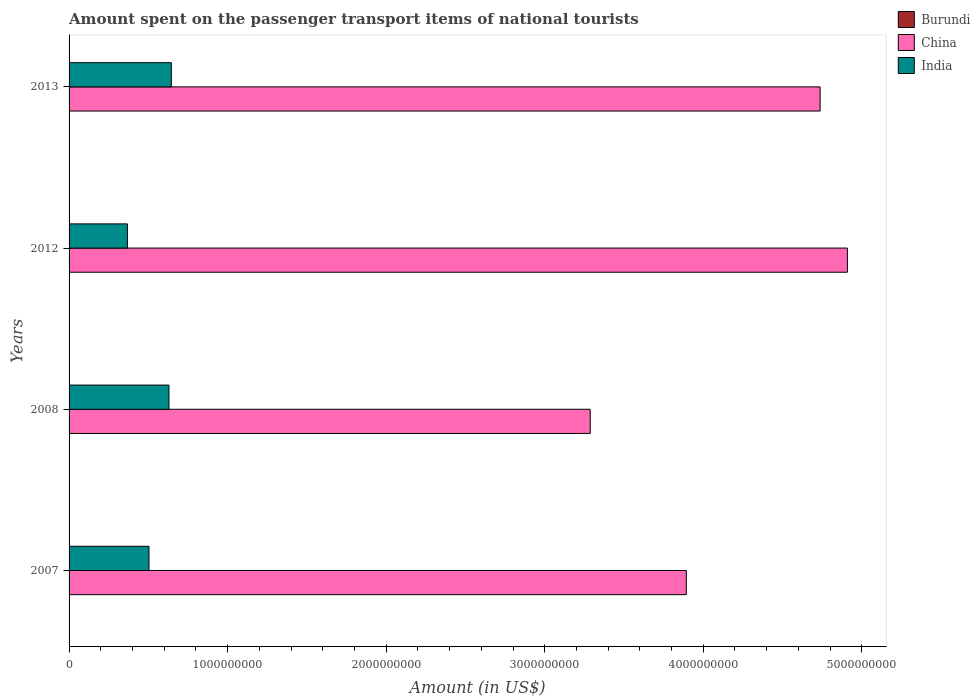How many different coloured bars are there?
Make the answer very short. 3. How many groups of bars are there?
Offer a very short reply. 4. Are the number of bars per tick equal to the number of legend labels?
Provide a short and direct response. Yes. Are the number of bars on each tick of the Y-axis equal?
Keep it short and to the point. Yes. How many bars are there on the 1st tick from the bottom?
Give a very brief answer. 3. What is the label of the 2nd group of bars from the top?
Offer a terse response. 2012. In how many cases, is the number of bars for a given year not equal to the number of legend labels?
Your answer should be compact. 0. What is the amount spent on the passenger transport items of national tourists in India in 2008?
Give a very brief answer. 6.30e+08. Across all years, what is the maximum amount spent on the passenger transport items of national tourists in China?
Provide a succinct answer. 4.91e+09. Across all years, what is the minimum amount spent on the passenger transport items of national tourists in Burundi?
Provide a short and direct response. 3.00e+05. In which year was the amount spent on the passenger transport items of national tourists in India maximum?
Make the answer very short. 2013. In which year was the amount spent on the passenger transport items of national tourists in China minimum?
Ensure brevity in your answer.  2008. What is the total amount spent on the passenger transport items of national tourists in China in the graph?
Your answer should be very brief. 1.68e+1. What is the difference between the amount spent on the passenger transport items of national tourists in India in 2007 and that in 2013?
Provide a succinct answer. -1.41e+08. What is the difference between the amount spent on the passenger transport items of national tourists in China in 2008 and the amount spent on the passenger transport items of national tourists in Burundi in 2007?
Your answer should be very brief. 3.29e+09. What is the average amount spent on the passenger transport items of national tourists in Burundi per year?
Give a very brief answer. 8.25e+05. In the year 2008, what is the difference between the amount spent on the passenger transport items of national tourists in Burundi and amount spent on the passenger transport items of national tourists in India?
Offer a terse response. -6.30e+08. In how many years, is the amount spent on the passenger transport items of national tourists in China greater than 600000000 US$?
Provide a succinct answer. 4. What is the ratio of the amount spent on the passenger transport items of national tourists in China in 2007 to that in 2008?
Keep it short and to the point. 1.18. Is the amount spent on the passenger transport items of national tourists in China in 2007 less than that in 2013?
Ensure brevity in your answer.  Yes. What is the difference between the highest and the second highest amount spent on the passenger transport items of national tourists in China?
Your answer should be compact. 1.72e+08. What is the difference between the highest and the lowest amount spent on the passenger transport items of national tourists in China?
Give a very brief answer. 1.62e+09. In how many years, is the amount spent on the passenger transport items of national tourists in Burundi greater than the average amount spent on the passenger transport items of national tourists in Burundi taken over all years?
Your answer should be compact. 2. Is it the case that in every year, the sum of the amount spent on the passenger transport items of national tourists in Burundi and amount spent on the passenger transport items of national tourists in India is greater than the amount spent on the passenger transport items of national tourists in China?
Give a very brief answer. No. How many bars are there?
Provide a short and direct response. 12. Are the values on the major ticks of X-axis written in scientific E-notation?
Make the answer very short. No. Where does the legend appear in the graph?
Offer a terse response. Top right. How are the legend labels stacked?
Make the answer very short. Vertical. What is the title of the graph?
Offer a very short reply. Amount spent on the passenger transport items of national tourists. What is the label or title of the Y-axis?
Provide a succinct answer. Years. What is the Amount (in US$) of Burundi in 2007?
Provide a succinct answer. 1.00e+06. What is the Amount (in US$) in China in 2007?
Make the answer very short. 3.89e+09. What is the Amount (in US$) in India in 2007?
Ensure brevity in your answer.  5.04e+08. What is the Amount (in US$) in China in 2008?
Keep it short and to the point. 3.29e+09. What is the Amount (in US$) in India in 2008?
Your answer should be compact. 6.30e+08. What is the Amount (in US$) in Burundi in 2012?
Offer a very short reply. 1.20e+06. What is the Amount (in US$) of China in 2012?
Your answer should be compact. 4.91e+09. What is the Amount (in US$) of India in 2012?
Keep it short and to the point. 3.68e+08. What is the Amount (in US$) in China in 2013?
Keep it short and to the point. 4.74e+09. What is the Amount (in US$) of India in 2013?
Provide a short and direct response. 6.45e+08. Across all years, what is the maximum Amount (in US$) of Burundi?
Your answer should be very brief. 1.20e+06. Across all years, what is the maximum Amount (in US$) of China?
Keep it short and to the point. 4.91e+09. Across all years, what is the maximum Amount (in US$) of India?
Offer a terse response. 6.45e+08. Across all years, what is the minimum Amount (in US$) in China?
Your answer should be very brief. 3.29e+09. Across all years, what is the minimum Amount (in US$) of India?
Provide a short and direct response. 3.68e+08. What is the total Amount (in US$) in Burundi in the graph?
Provide a short and direct response. 3.30e+06. What is the total Amount (in US$) in China in the graph?
Ensure brevity in your answer.  1.68e+1. What is the total Amount (in US$) in India in the graph?
Ensure brevity in your answer.  2.15e+09. What is the difference between the Amount (in US$) of China in 2007 and that in 2008?
Offer a very short reply. 6.06e+08. What is the difference between the Amount (in US$) of India in 2007 and that in 2008?
Offer a terse response. -1.26e+08. What is the difference between the Amount (in US$) in Burundi in 2007 and that in 2012?
Give a very brief answer. -2.00e+05. What is the difference between the Amount (in US$) in China in 2007 and that in 2012?
Offer a very short reply. -1.02e+09. What is the difference between the Amount (in US$) in India in 2007 and that in 2012?
Offer a very short reply. 1.36e+08. What is the difference between the Amount (in US$) of Burundi in 2007 and that in 2013?
Offer a very short reply. 2.00e+05. What is the difference between the Amount (in US$) in China in 2007 and that in 2013?
Provide a short and direct response. -8.44e+08. What is the difference between the Amount (in US$) in India in 2007 and that in 2013?
Provide a short and direct response. -1.41e+08. What is the difference between the Amount (in US$) in Burundi in 2008 and that in 2012?
Make the answer very short. -9.00e+05. What is the difference between the Amount (in US$) of China in 2008 and that in 2012?
Provide a short and direct response. -1.62e+09. What is the difference between the Amount (in US$) in India in 2008 and that in 2012?
Make the answer very short. 2.62e+08. What is the difference between the Amount (in US$) of Burundi in 2008 and that in 2013?
Make the answer very short. -5.00e+05. What is the difference between the Amount (in US$) of China in 2008 and that in 2013?
Give a very brief answer. -1.45e+09. What is the difference between the Amount (in US$) in India in 2008 and that in 2013?
Ensure brevity in your answer.  -1.50e+07. What is the difference between the Amount (in US$) in Burundi in 2012 and that in 2013?
Make the answer very short. 4.00e+05. What is the difference between the Amount (in US$) of China in 2012 and that in 2013?
Make the answer very short. 1.72e+08. What is the difference between the Amount (in US$) in India in 2012 and that in 2013?
Give a very brief answer. -2.77e+08. What is the difference between the Amount (in US$) of Burundi in 2007 and the Amount (in US$) of China in 2008?
Give a very brief answer. -3.29e+09. What is the difference between the Amount (in US$) in Burundi in 2007 and the Amount (in US$) in India in 2008?
Offer a terse response. -6.29e+08. What is the difference between the Amount (in US$) in China in 2007 and the Amount (in US$) in India in 2008?
Keep it short and to the point. 3.26e+09. What is the difference between the Amount (in US$) in Burundi in 2007 and the Amount (in US$) in China in 2012?
Your answer should be very brief. -4.91e+09. What is the difference between the Amount (in US$) of Burundi in 2007 and the Amount (in US$) of India in 2012?
Your answer should be compact. -3.67e+08. What is the difference between the Amount (in US$) in China in 2007 and the Amount (in US$) in India in 2012?
Your response must be concise. 3.52e+09. What is the difference between the Amount (in US$) of Burundi in 2007 and the Amount (in US$) of China in 2013?
Offer a terse response. -4.74e+09. What is the difference between the Amount (in US$) of Burundi in 2007 and the Amount (in US$) of India in 2013?
Offer a very short reply. -6.44e+08. What is the difference between the Amount (in US$) of China in 2007 and the Amount (in US$) of India in 2013?
Offer a very short reply. 3.25e+09. What is the difference between the Amount (in US$) in Burundi in 2008 and the Amount (in US$) in China in 2012?
Provide a short and direct response. -4.91e+09. What is the difference between the Amount (in US$) of Burundi in 2008 and the Amount (in US$) of India in 2012?
Ensure brevity in your answer.  -3.68e+08. What is the difference between the Amount (in US$) in China in 2008 and the Amount (in US$) in India in 2012?
Keep it short and to the point. 2.92e+09. What is the difference between the Amount (in US$) of Burundi in 2008 and the Amount (in US$) of China in 2013?
Ensure brevity in your answer.  -4.74e+09. What is the difference between the Amount (in US$) in Burundi in 2008 and the Amount (in US$) in India in 2013?
Offer a terse response. -6.45e+08. What is the difference between the Amount (in US$) of China in 2008 and the Amount (in US$) of India in 2013?
Give a very brief answer. 2.64e+09. What is the difference between the Amount (in US$) of Burundi in 2012 and the Amount (in US$) of China in 2013?
Keep it short and to the point. -4.74e+09. What is the difference between the Amount (in US$) of Burundi in 2012 and the Amount (in US$) of India in 2013?
Give a very brief answer. -6.44e+08. What is the difference between the Amount (in US$) of China in 2012 and the Amount (in US$) of India in 2013?
Give a very brief answer. 4.26e+09. What is the average Amount (in US$) of Burundi per year?
Offer a very short reply. 8.25e+05. What is the average Amount (in US$) of China per year?
Give a very brief answer. 4.21e+09. What is the average Amount (in US$) of India per year?
Your answer should be very brief. 5.37e+08. In the year 2007, what is the difference between the Amount (in US$) of Burundi and Amount (in US$) of China?
Your answer should be very brief. -3.89e+09. In the year 2007, what is the difference between the Amount (in US$) of Burundi and Amount (in US$) of India?
Your answer should be very brief. -5.03e+08. In the year 2007, what is the difference between the Amount (in US$) of China and Amount (in US$) of India?
Your answer should be very brief. 3.39e+09. In the year 2008, what is the difference between the Amount (in US$) in Burundi and Amount (in US$) in China?
Give a very brief answer. -3.29e+09. In the year 2008, what is the difference between the Amount (in US$) in Burundi and Amount (in US$) in India?
Provide a short and direct response. -6.30e+08. In the year 2008, what is the difference between the Amount (in US$) in China and Amount (in US$) in India?
Your answer should be compact. 2.66e+09. In the year 2012, what is the difference between the Amount (in US$) in Burundi and Amount (in US$) in China?
Keep it short and to the point. -4.91e+09. In the year 2012, what is the difference between the Amount (in US$) of Burundi and Amount (in US$) of India?
Provide a short and direct response. -3.67e+08. In the year 2012, what is the difference between the Amount (in US$) of China and Amount (in US$) of India?
Offer a very short reply. 4.54e+09. In the year 2013, what is the difference between the Amount (in US$) in Burundi and Amount (in US$) in China?
Your answer should be very brief. -4.74e+09. In the year 2013, what is the difference between the Amount (in US$) in Burundi and Amount (in US$) in India?
Ensure brevity in your answer.  -6.44e+08. In the year 2013, what is the difference between the Amount (in US$) of China and Amount (in US$) of India?
Offer a very short reply. 4.09e+09. What is the ratio of the Amount (in US$) in Burundi in 2007 to that in 2008?
Give a very brief answer. 3.33. What is the ratio of the Amount (in US$) of China in 2007 to that in 2008?
Keep it short and to the point. 1.18. What is the ratio of the Amount (in US$) in Burundi in 2007 to that in 2012?
Your answer should be very brief. 0.83. What is the ratio of the Amount (in US$) of China in 2007 to that in 2012?
Make the answer very short. 0.79. What is the ratio of the Amount (in US$) in India in 2007 to that in 2012?
Offer a terse response. 1.37. What is the ratio of the Amount (in US$) in China in 2007 to that in 2013?
Give a very brief answer. 0.82. What is the ratio of the Amount (in US$) in India in 2007 to that in 2013?
Keep it short and to the point. 0.78. What is the ratio of the Amount (in US$) in China in 2008 to that in 2012?
Make the answer very short. 0.67. What is the ratio of the Amount (in US$) of India in 2008 to that in 2012?
Your answer should be very brief. 1.71. What is the ratio of the Amount (in US$) of China in 2008 to that in 2013?
Offer a terse response. 0.69. What is the ratio of the Amount (in US$) in India in 2008 to that in 2013?
Your response must be concise. 0.98. What is the ratio of the Amount (in US$) in Burundi in 2012 to that in 2013?
Your answer should be very brief. 1.5. What is the ratio of the Amount (in US$) of China in 2012 to that in 2013?
Your answer should be compact. 1.04. What is the ratio of the Amount (in US$) of India in 2012 to that in 2013?
Provide a short and direct response. 0.57. What is the difference between the highest and the second highest Amount (in US$) of China?
Make the answer very short. 1.72e+08. What is the difference between the highest and the second highest Amount (in US$) in India?
Ensure brevity in your answer.  1.50e+07. What is the difference between the highest and the lowest Amount (in US$) of China?
Provide a succinct answer. 1.62e+09. What is the difference between the highest and the lowest Amount (in US$) of India?
Your answer should be compact. 2.77e+08. 